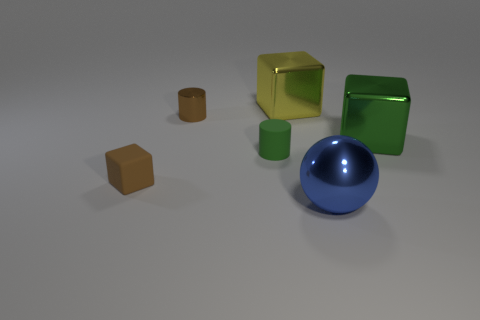Subtract all large shiny cubes. How many cubes are left? 1 Add 4 big blue shiny things. How many objects exist? 10 Subtract all cylinders. How many objects are left? 4 Subtract 3 cubes. How many cubes are left? 0 Subtract all small brown cubes. Subtract all large yellow metal cubes. How many objects are left? 4 Add 4 brown rubber objects. How many brown rubber objects are left? 5 Add 3 big green shiny cylinders. How many big green shiny cylinders exist? 3 Subtract 0 cyan cylinders. How many objects are left? 6 Subtract all yellow cubes. Subtract all brown cylinders. How many cubes are left? 2 